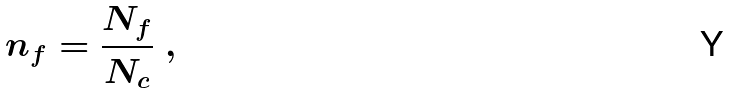Convert formula to latex. <formula><loc_0><loc_0><loc_500><loc_500>n _ { f } = \frac { N _ { f } } { N _ { c } } \ ,</formula> 